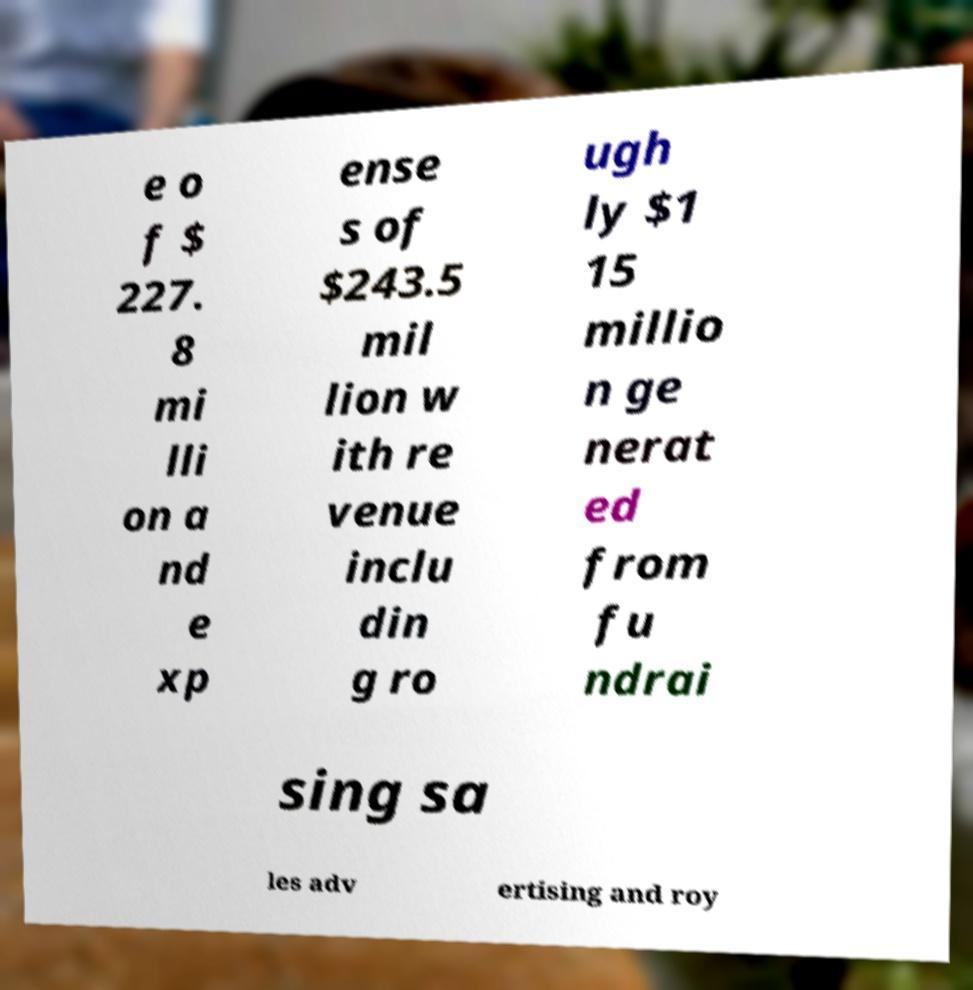There's text embedded in this image that I need extracted. Can you transcribe it verbatim? e o f $ 227. 8 mi lli on a nd e xp ense s of $243.5 mil lion w ith re venue inclu din g ro ugh ly $1 15 millio n ge nerat ed from fu ndrai sing sa les adv ertising and roy 